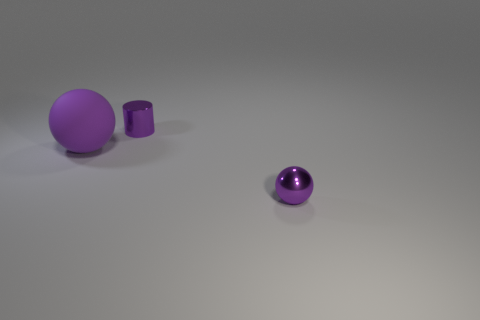What objects are present in this image, and how do they differ from each other? The image shows three objects: a large matte purple sphere, a small shiny purple cylinder, and a small shiny purple sphere. The large sphere and the small cylinder have a matte finish, while the small spheres are shiny, reflecting light. Moreover, the objects vary in shape and size. 